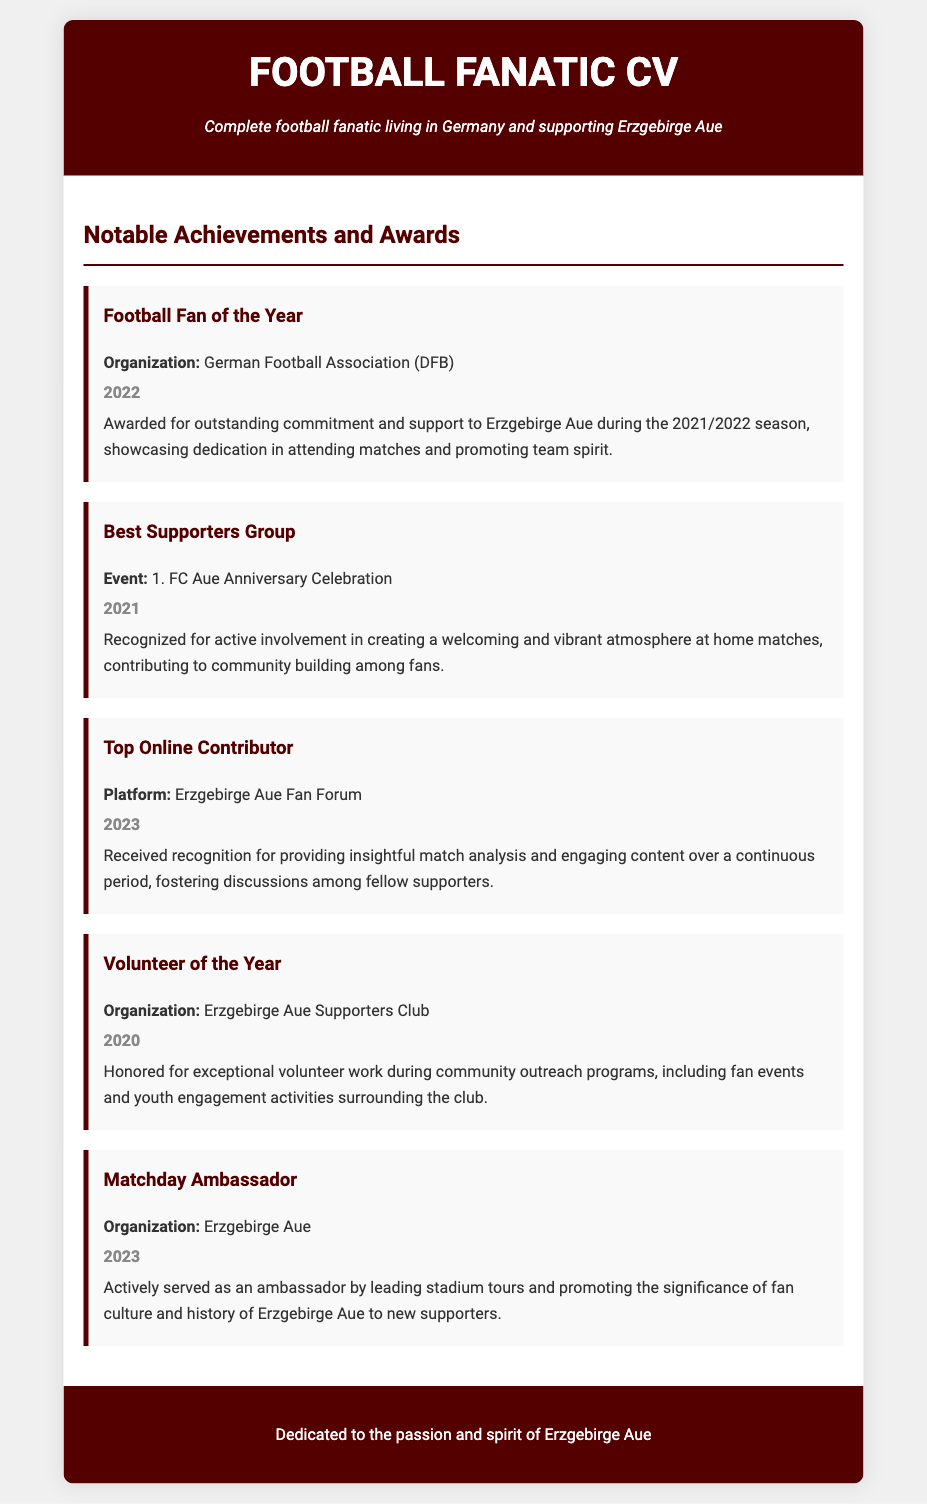what award was received in 2022? The award received in 2022 was "Football Fan of the Year".
Answer: Football Fan of the Year who organized the "Best Supporters Group" award? The "Best Supporters Group" award was organized by 1. FC Aue Anniversary Celebration.
Answer: 1. FC Aue Anniversary Celebration what achievement did the individual receive in 2023 regarding online contributions? The achievement received in 2023 was "Top Online Contributor".
Answer: Top Online Contributor which organization honored the individual as "Volunteer of the Year"? The organization that honored the individual as "Volunteer of the Year" was the Erzgebirge Aue Supporters Club.
Answer: Erzgebirge Aue Supporters Club how many notable achievements are listed in the document? The document lists a total of 5 notable achievements.
Answer: 5 